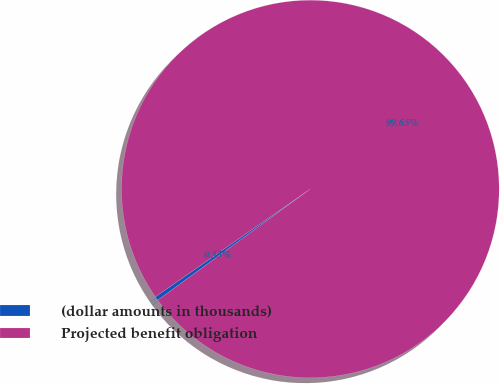Convert chart to OTSL. <chart><loc_0><loc_0><loc_500><loc_500><pie_chart><fcel>(dollar amounts in thousands)<fcel>Projected benefit obligation<nl><fcel>0.35%<fcel>99.65%<nl></chart> 